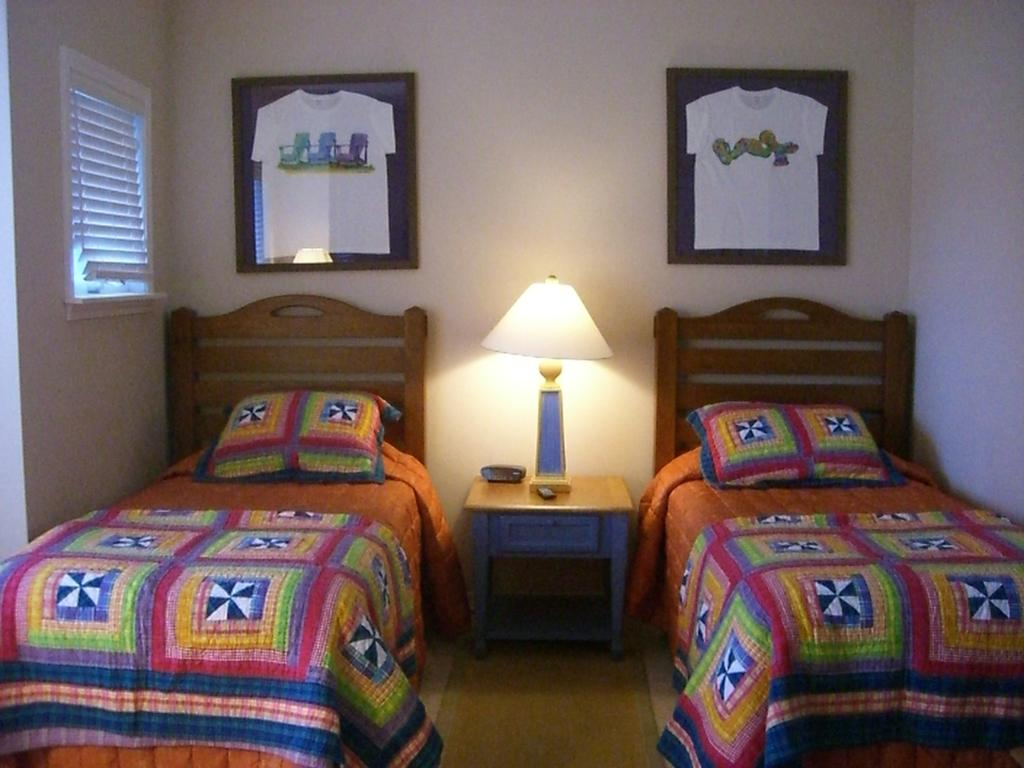How many beds are in the image? There are two beds in the image. What is on top of the beds? The beds have blankets and pillows on them. What can be found on the table in the image? The table has a lamp on it. What is hanging on the wall in the image? There are two frames on the wall. Is there a source of natural light in the image? Yes, there is a window in the image. What type of question is being asked in the image? There is no question being asked in the image; it is a still image of a room with beds, blankets, pillows, a table, a lamp, frames, and a window. 